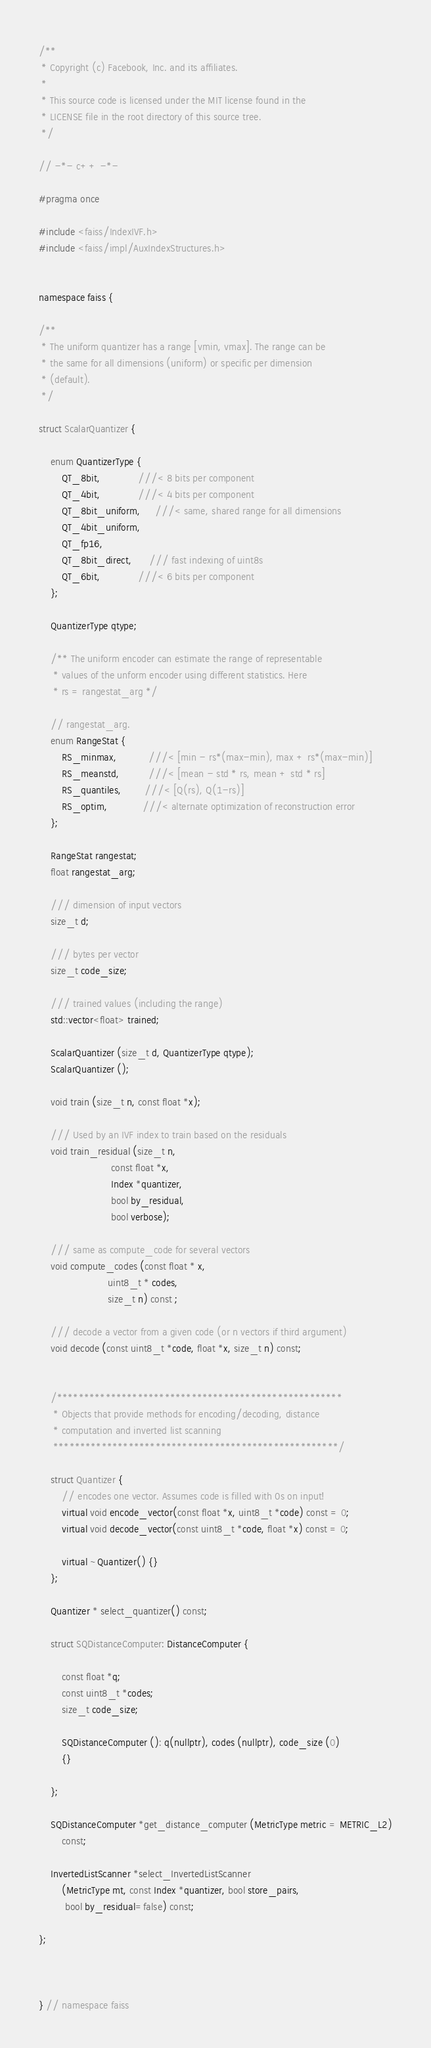<code> <loc_0><loc_0><loc_500><loc_500><_C_>/**
 * Copyright (c) Facebook, Inc. and its affiliates.
 *
 * This source code is licensed under the MIT license found in the
 * LICENSE file in the root directory of this source tree.
 */

// -*- c++ -*-

#pragma once

#include <faiss/IndexIVF.h>
#include <faiss/impl/AuxIndexStructures.h>


namespace faiss {

/**
 * The uniform quantizer has a range [vmin, vmax]. The range can be
 * the same for all dimensions (uniform) or specific per dimension
 * (default).
 */

struct ScalarQuantizer {

    enum QuantizerType {
        QT_8bit,             ///< 8 bits per component
        QT_4bit,             ///< 4 bits per component
        QT_8bit_uniform,     ///< same, shared range for all dimensions
        QT_4bit_uniform,
        QT_fp16,
        QT_8bit_direct,      /// fast indexing of uint8s
        QT_6bit,             ///< 6 bits per component
    };

    QuantizerType qtype;

    /** The uniform encoder can estimate the range of representable
     * values of the unform encoder using different statistics. Here
     * rs = rangestat_arg */

    // rangestat_arg.
    enum RangeStat {
        RS_minmax,           ///< [min - rs*(max-min), max + rs*(max-min)]
        RS_meanstd,          ///< [mean - std * rs, mean + std * rs]
        RS_quantiles,        ///< [Q(rs), Q(1-rs)]
        RS_optim,            ///< alternate optimization of reconstruction error
    };

    RangeStat rangestat;
    float rangestat_arg;

    /// dimension of input vectors
    size_t d;

    /// bytes per vector
    size_t code_size;

    /// trained values (including the range)
    std::vector<float> trained;

    ScalarQuantizer (size_t d, QuantizerType qtype);
    ScalarQuantizer ();

    void train (size_t n, const float *x);

    /// Used by an IVF index to train based on the residuals
    void train_residual (size_t n,
                         const float *x,
                         Index *quantizer,
                         bool by_residual,
                         bool verbose);

    /// same as compute_code for several vectors
    void compute_codes (const float * x,
                        uint8_t * codes,
                        size_t n) const ;

    /// decode a vector from a given code (or n vectors if third argument)
    void decode (const uint8_t *code, float *x, size_t n) const;


    /*****************************************************
     * Objects that provide methods for encoding/decoding, distance
     * computation and inverted list scanning
     *****************************************************/

    struct Quantizer {
        // encodes one vector. Assumes code is filled with 0s on input!
        virtual void encode_vector(const float *x, uint8_t *code) const = 0;
        virtual void decode_vector(const uint8_t *code, float *x) const = 0;

        virtual ~Quantizer() {}
    };

    Quantizer * select_quantizer() const;

    struct SQDistanceComputer: DistanceComputer {

        const float *q;
        const uint8_t *codes;
        size_t code_size;

        SQDistanceComputer (): q(nullptr), codes (nullptr), code_size (0)
        {}

    };

    SQDistanceComputer *get_distance_computer (MetricType metric = METRIC_L2)
        const;

    InvertedListScanner *select_InvertedListScanner
        (MetricType mt, const Index *quantizer, bool store_pairs,
         bool by_residual=false) const;

};



} // namespace faiss
</code> 